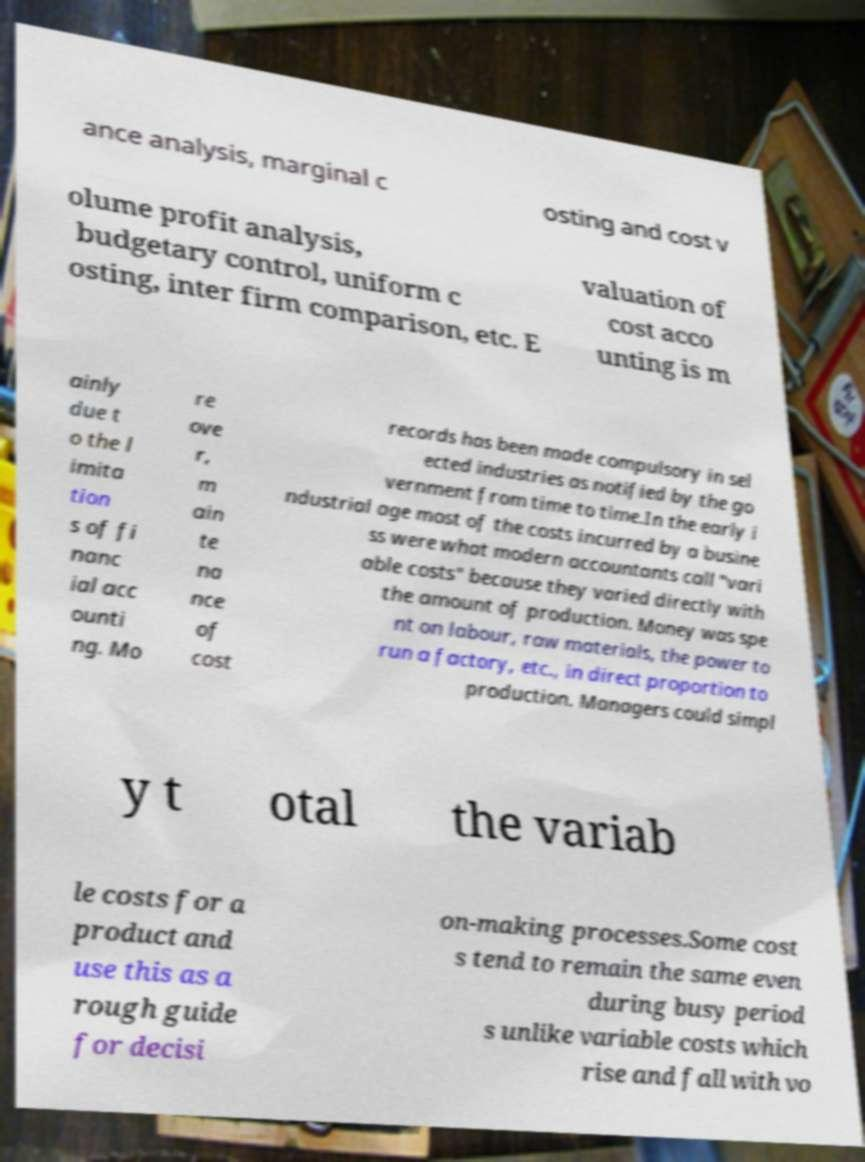Could you assist in decoding the text presented in this image and type it out clearly? ance analysis, marginal c osting and cost v olume profit analysis, budgetary control, uniform c osting, inter firm comparison, etc. E valuation of cost acco unting is m ainly due t o the l imita tion s of fi nanc ial acc ounti ng. Mo re ove r, m ain te na nce of cost records has been made compulsory in sel ected industries as notified by the go vernment from time to time.In the early i ndustrial age most of the costs incurred by a busine ss were what modern accountants call "vari able costs" because they varied directly with the amount of production. Money was spe nt on labour, raw materials, the power to run a factory, etc., in direct proportion to production. Managers could simpl y t otal the variab le costs for a product and use this as a rough guide for decisi on-making processes.Some cost s tend to remain the same even during busy period s unlike variable costs which rise and fall with vo 